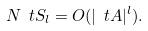Convert formula to latex. <formula><loc_0><loc_0><loc_500><loc_500>N \ t S _ { l } = O ( | \ t A | ^ { l } ) .</formula> 